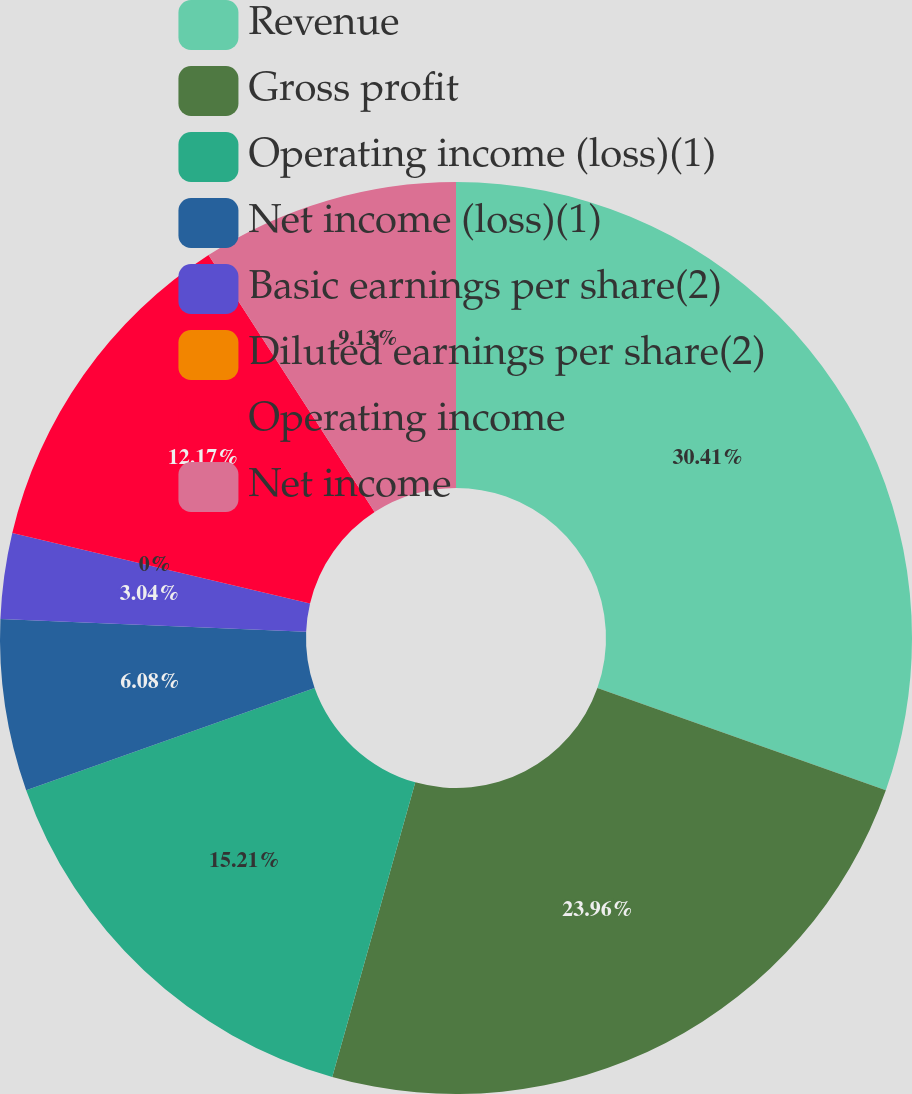Convert chart to OTSL. <chart><loc_0><loc_0><loc_500><loc_500><pie_chart><fcel>Revenue<fcel>Gross profit<fcel>Operating income (loss)(1)<fcel>Net income (loss)(1)<fcel>Basic earnings per share(2)<fcel>Diluted earnings per share(2)<fcel>Operating income<fcel>Net income<nl><fcel>30.42%<fcel>23.96%<fcel>15.21%<fcel>6.08%<fcel>3.04%<fcel>0.0%<fcel>12.17%<fcel>9.13%<nl></chart> 